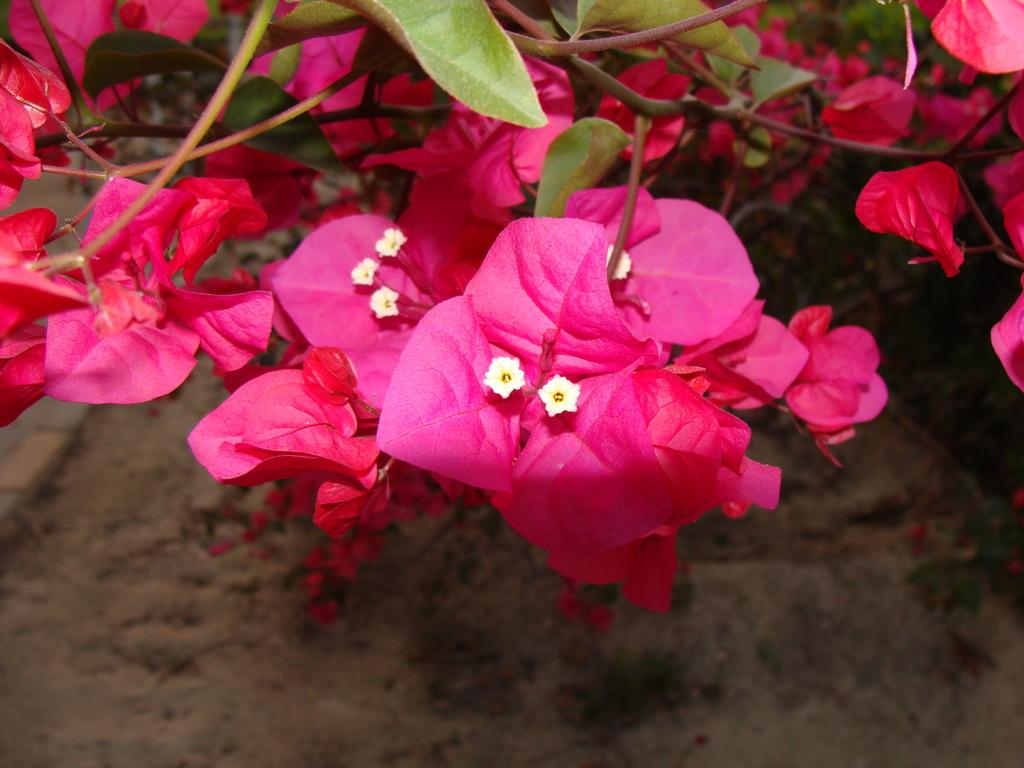What type of living organisms can be seen in the image? Flowers can be seen in the image. Where are the flowers located? The flowers are on a plant. What is the position of the plant in the image? The plant is on the ground. What type of fiction can be seen in the image? There is no fiction present in the image; it features flowers on a plant. What angle is the plant positioned at in the image? The angle of the plant in the image cannot be determined from the provided facts. 